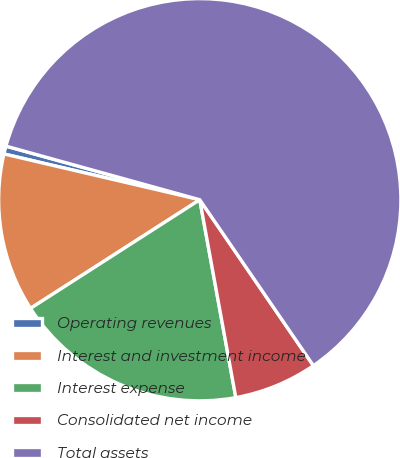<chart> <loc_0><loc_0><loc_500><loc_500><pie_chart><fcel>Operating revenues<fcel>Interest and investment income<fcel>Interest expense<fcel>Consolidated net income<fcel>Total assets<nl><fcel>0.64%<fcel>12.74%<fcel>18.79%<fcel>6.69%<fcel>61.15%<nl></chart> 